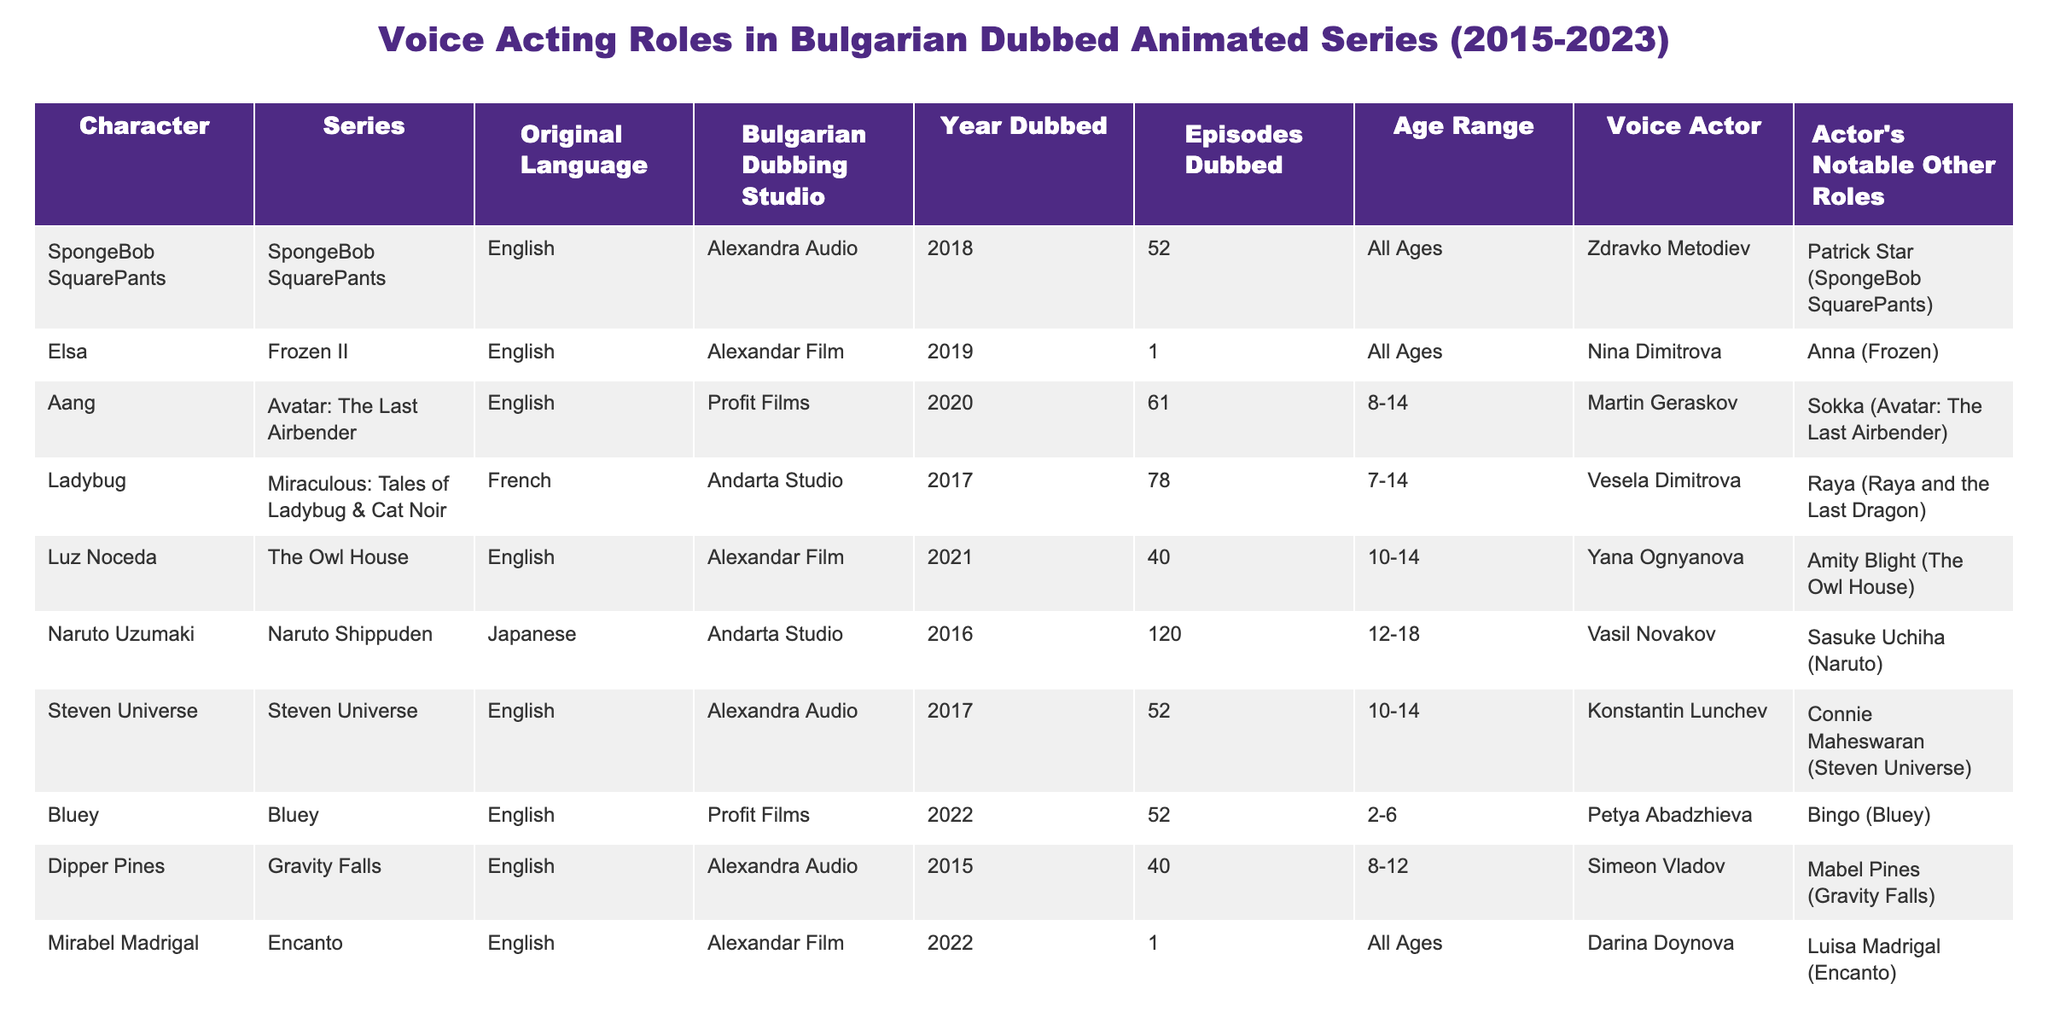What character was voiced by Zdravko Metodiev? Looking at the table, Zdravko Metodiev is listed as the voice actor for the character SpongeBob SquarePants.
Answer: SpongeBob SquarePants Which series had the most episodes dubbed? By examining the 'Episodes Dubbed' column, Naruto Shippuden has the highest value with 120 episodes.
Answer: Naruto Shippuden Is Elsa from Frozen II dubbed in Bulgarian? The table indicates that Elsa from Frozen II is indeed listed and categorized under the Bulgarian dubbing roles.
Answer: Yes Who voiced Mirabel Madrigal in Encanto? The table shows that Darina Doynova is the voice actor for Mirabel Madrigal from Encanto.
Answer: Darina Doynova What is the total number of episodes dubbed for all the characters combined? Adding the episodes: 52 + 1 + 61 + 78 + 40 + 120 + 52 + 52 + 1 = 407. Therefore, the total is 407 episodes.
Answer: 407 Which voice actor has the most characters listed in the table? Reviewing the table, it appears that some actors have voiced multiple characters. Specifically, Zdravko Metodiev voiced SpongeBob SquarePants. Others only appear once.
Answer: Zdravko Metodiev Are there any characters voiced by actors who have played roles in other animations? Checking the 'Actor's Notable Other Roles', multiple characters like Aang, voiced by Martin Geraskov, indicate previous roles in other animations.
Answer: Yes Which characters fall within the age range of 10-14? From scanning the 'Age Range' column, the characters Aang, Luz Noceda, and Steven Universe fall within the specified range.
Answer: Aang, Luz Noceda, Steven Universe Is there a character from a French series in the table? The table indicates that Ladybug from Miraculous: Tales of Ladybug & Cat Noir is the only character that originates from a French series.
Answer: Yes Who voiced the character Dipper Pines in Gravity Falls? According to the table, Simeon Vladov is noted as the actor who voiced Dipper Pines.
Answer: Simeon Vladov 